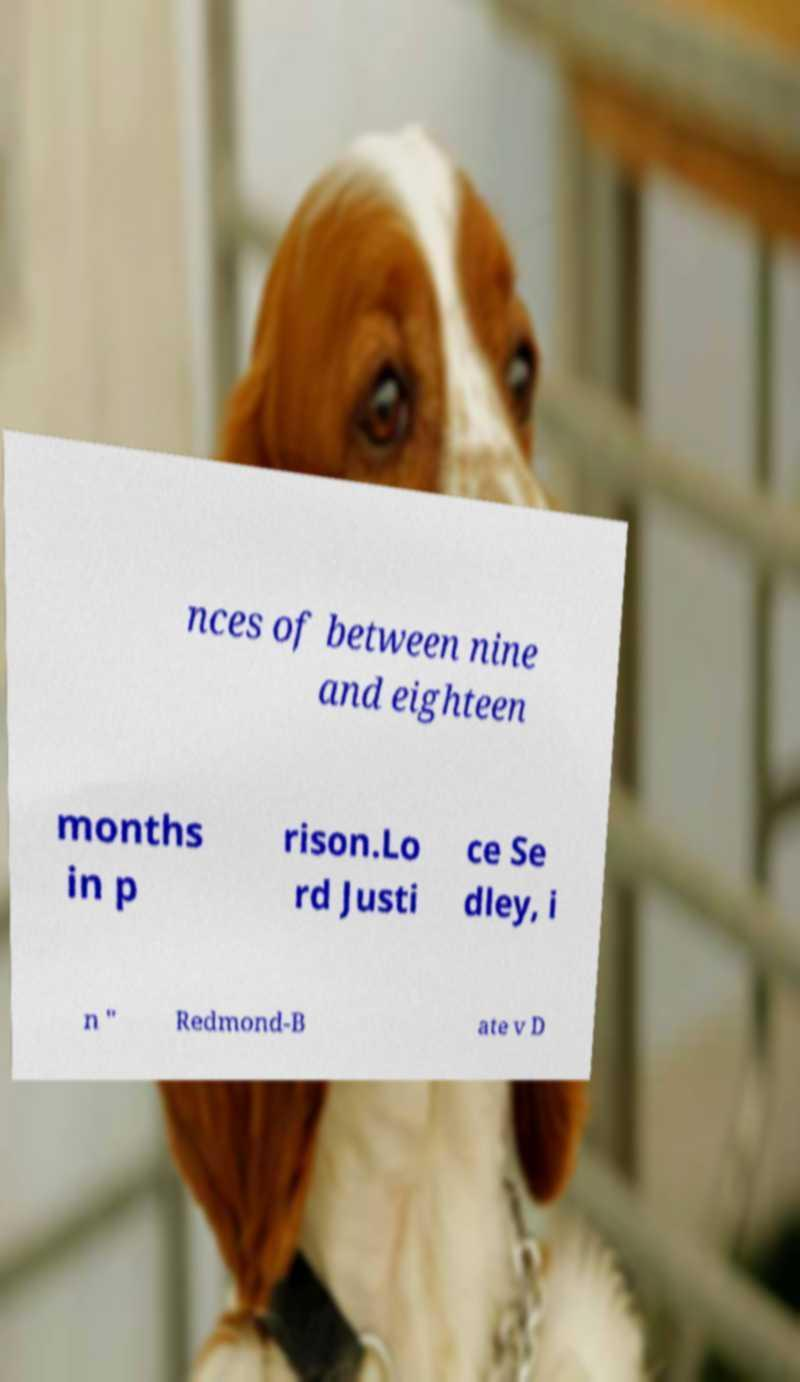Please read and relay the text visible in this image. What does it say? nces of between nine and eighteen months in p rison.Lo rd Justi ce Se dley, i n " Redmond-B ate v D 